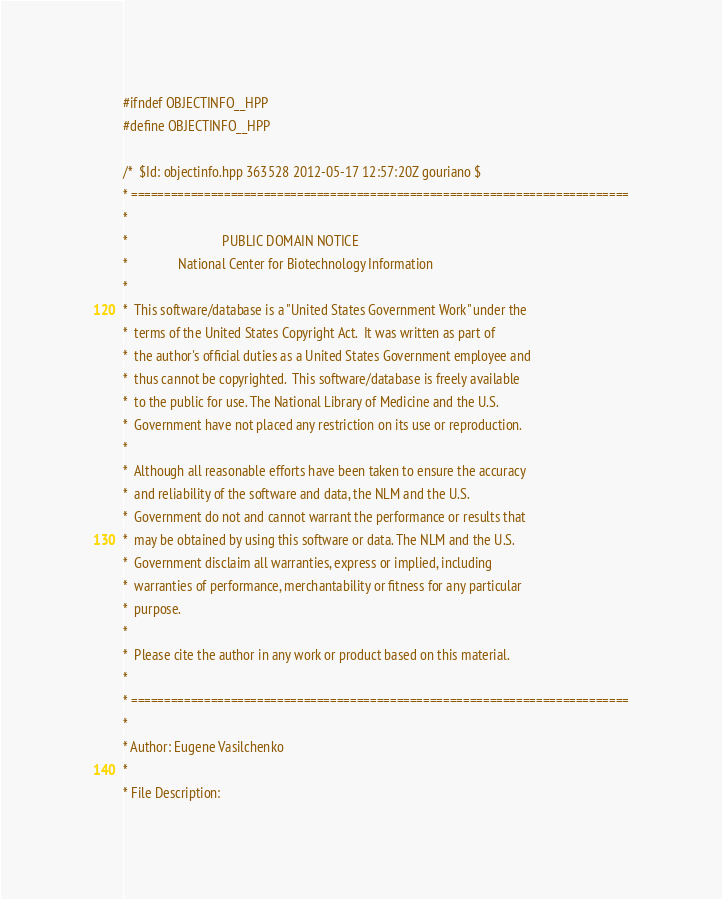Convert code to text. <code><loc_0><loc_0><loc_500><loc_500><_C++_>#ifndef OBJECTINFO__HPP
#define OBJECTINFO__HPP

/*  $Id: objectinfo.hpp 363528 2012-05-17 12:57:20Z gouriano $
* ===========================================================================
*
*                            PUBLIC DOMAIN NOTICE
*               National Center for Biotechnology Information
*
*  This software/database is a "United States Government Work" under the
*  terms of the United States Copyright Act.  It was written as part of
*  the author's official duties as a United States Government employee and
*  thus cannot be copyrighted.  This software/database is freely available
*  to the public for use. The National Library of Medicine and the U.S.
*  Government have not placed any restriction on its use or reproduction.
*
*  Although all reasonable efforts have been taken to ensure the accuracy
*  and reliability of the software and data, the NLM and the U.S.
*  Government do not and cannot warrant the performance or results that
*  may be obtained by using this software or data. The NLM and the U.S.
*  Government disclaim all warranties, express or implied, including
*  warranties of performance, merchantability or fitness for any particular
*  purpose.
*
*  Please cite the author in any work or product based on this material.
*
* ===========================================================================
*
* Author: Eugene Vasilchenko
*
* File Description:</code> 